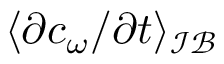Convert formula to latex. <formula><loc_0><loc_0><loc_500><loc_500>\langle \partial c _ { \omega } / \partial t \rangle _ { \mathcal { I B } }</formula> 